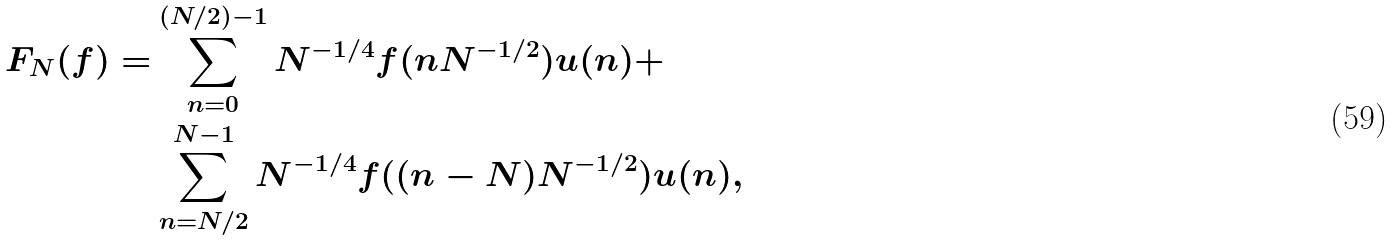<formula> <loc_0><loc_0><loc_500><loc_500>F _ { N } ( f ) = & \sum _ { n = 0 } ^ { ( N / 2 ) - 1 } N ^ { - 1 / 4 } f ( n N ^ { - 1 / 2 } ) u ( n ) + \\ & \sum _ { n = N / 2 } ^ { N - 1 } N ^ { - 1 / 4 } f ( ( n - N ) N ^ { - 1 / 2 } ) u ( n ) ,</formula> 